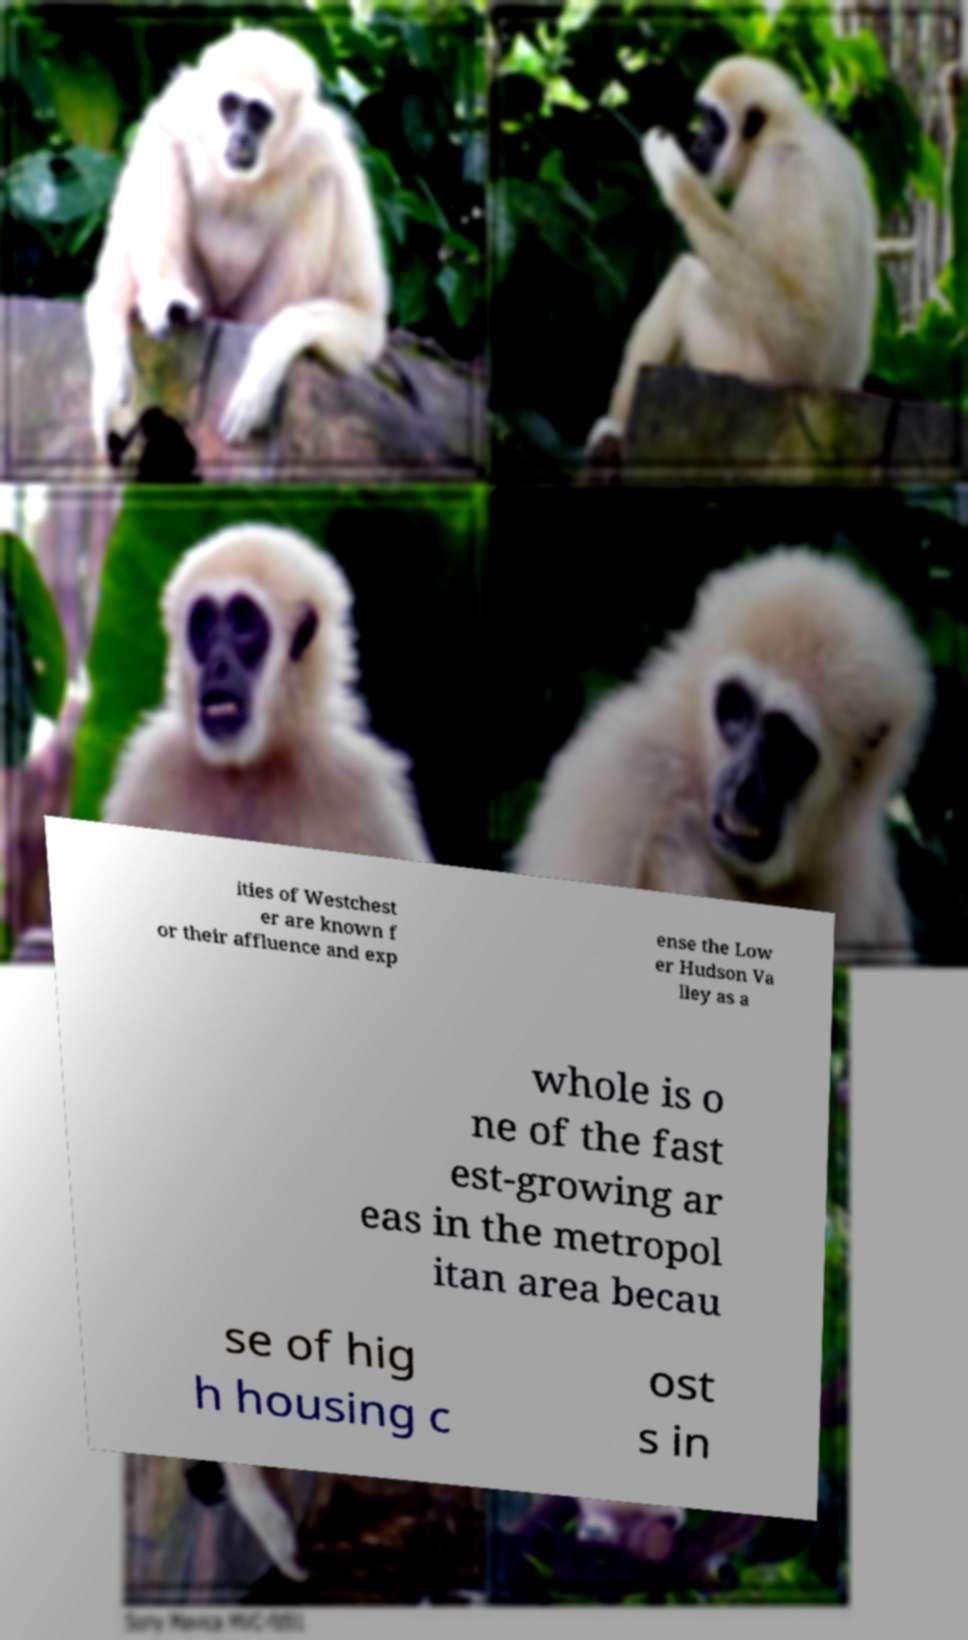Please identify and transcribe the text found in this image. ities of Westchest er are known f or their affluence and exp ense the Low er Hudson Va lley as a whole is o ne of the fast est-growing ar eas in the metropol itan area becau se of hig h housing c ost s in 